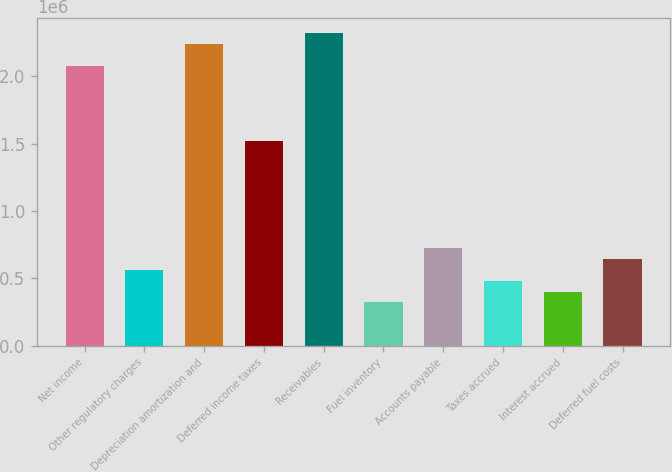Convert chart to OTSL. <chart><loc_0><loc_0><loc_500><loc_500><bar_chart><fcel>Net income<fcel>Other regulatory charges<fcel>Depreciation amortization and<fcel>Deferred income taxes<fcel>Receivables<fcel>Fuel inventory<fcel>Accounts payable<fcel>Taxes accrued<fcel>Interest accrued<fcel>Deferred fuel costs<nl><fcel>2.08141e+06<fcel>561515<fcel>2.2414e+06<fcel>1.52145e+06<fcel>2.3214e+06<fcel>321531<fcel>721504<fcel>481521<fcel>401526<fcel>641510<nl></chart> 